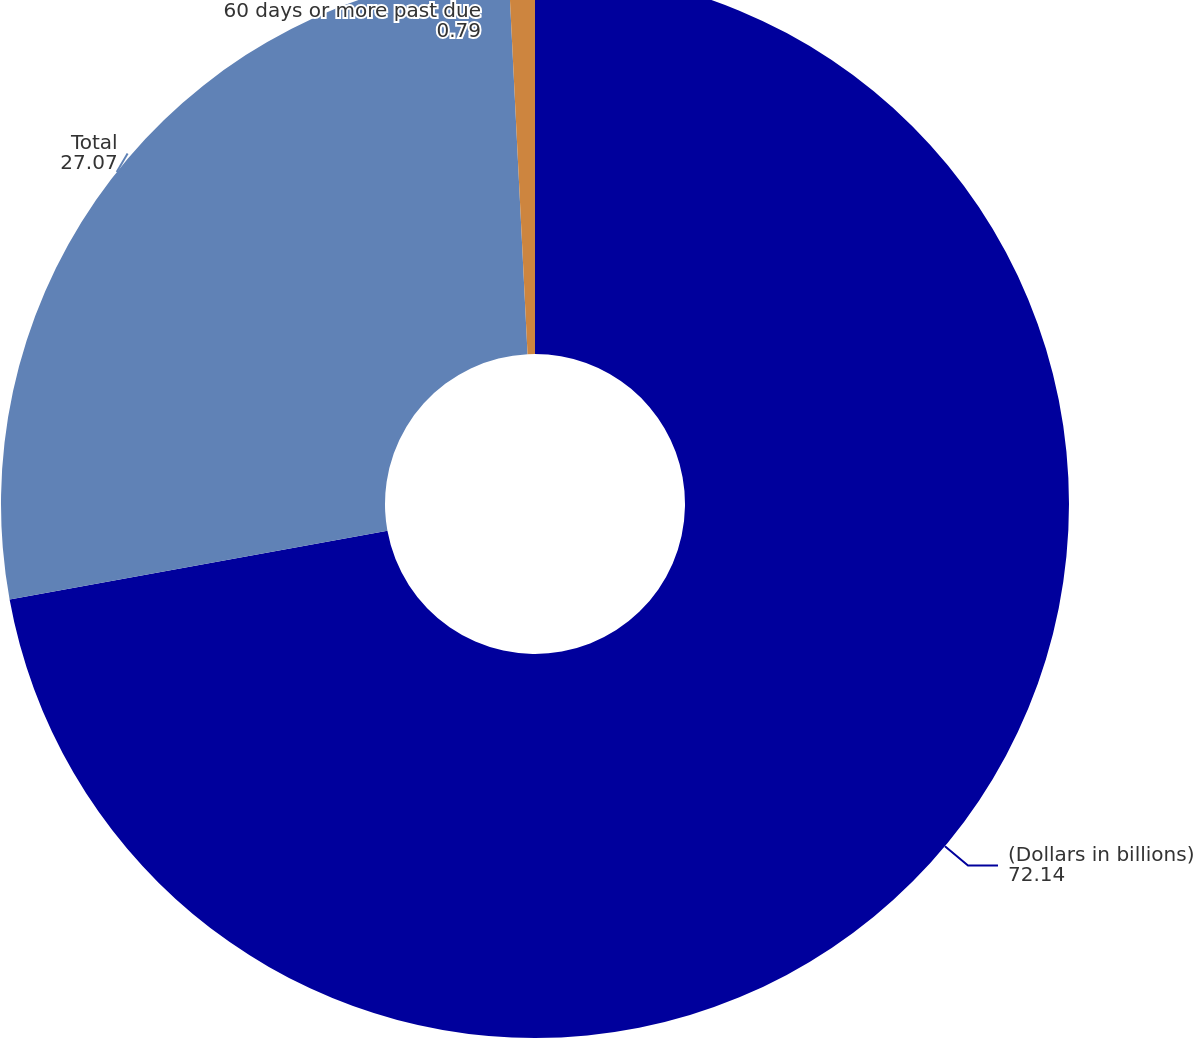Convert chart. <chart><loc_0><loc_0><loc_500><loc_500><pie_chart><fcel>(Dollars in billions)<fcel>Total<fcel>60 days or more past due<nl><fcel>72.14%<fcel>27.07%<fcel>0.79%<nl></chart> 